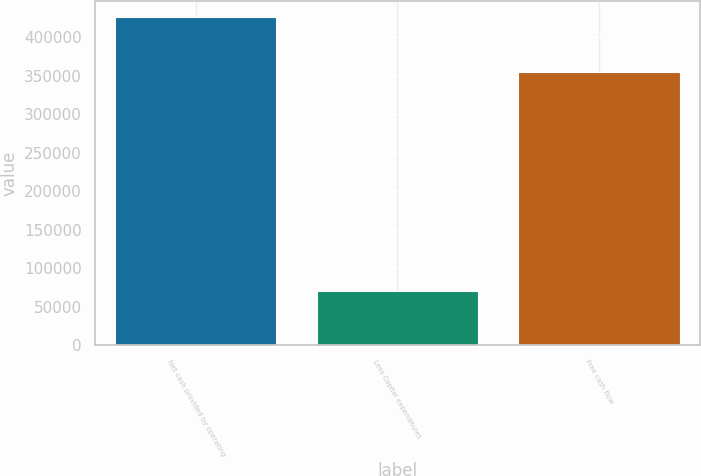Convert chart to OTSL. <chart><loc_0><loc_0><loc_500><loc_500><bar_chart><fcel>Net cash provided by operating<fcel>Less Capital expenditures<fcel>Free cash flow<nl><fcel>426301<fcel>70903<fcel>355398<nl></chart> 